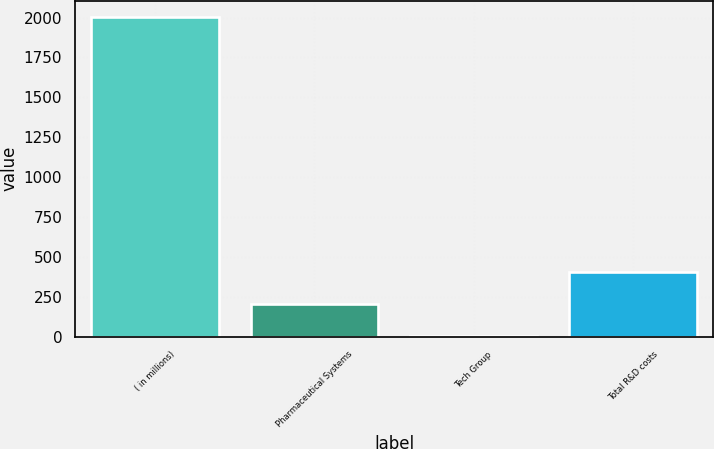Convert chart. <chart><loc_0><loc_0><loc_500><loc_500><bar_chart><fcel>( in millions)<fcel>Pharmaceutical Systems<fcel>Tech Group<fcel>Total R&D costs<nl><fcel>2006<fcel>202.76<fcel>2.4<fcel>403.12<nl></chart> 